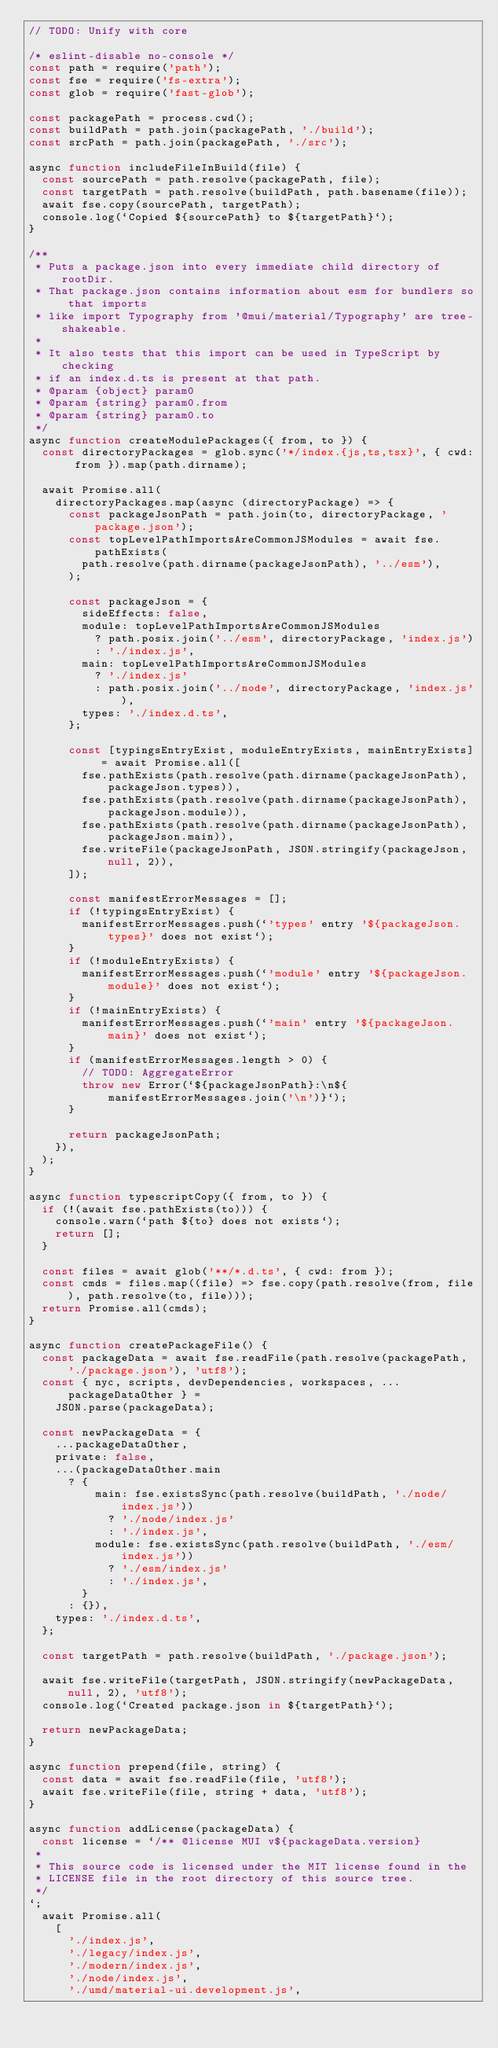Convert code to text. <code><loc_0><loc_0><loc_500><loc_500><_JavaScript_>// TODO: Unify with core

/* eslint-disable no-console */
const path = require('path');
const fse = require('fs-extra');
const glob = require('fast-glob');

const packagePath = process.cwd();
const buildPath = path.join(packagePath, './build');
const srcPath = path.join(packagePath, './src');

async function includeFileInBuild(file) {
  const sourcePath = path.resolve(packagePath, file);
  const targetPath = path.resolve(buildPath, path.basename(file));
  await fse.copy(sourcePath, targetPath);
  console.log(`Copied ${sourcePath} to ${targetPath}`);
}

/**
 * Puts a package.json into every immediate child directory of rootDir.
 * That package.json contains information about esm for bundlers so that imports
 * like import Typography from '@mui/material/Typography' are tree-shakeable.
 *
 * It also tests that this import can be used in TypeScript by checking
 * if an index.d.ts is present at that path.
 * @param {object} param0
 * @param {string} param0.from
 * @param {string} param0.to
 */
async function createModulePackages({ from, to }) {
  const directoryPackages = glob.sync('*/index.{js,ts,tsx}', { cwd: from }).map(path.dirname);

  await Promise.all(
    directoryPackages.map(async (directoryPackage) => {
      const packageJsonPath = path.join(to, directoryPackage, 'package.json');
      const topLevelPathImportsAreCommonJSModules = await fse.pathExists(
        path.resolve(path.dirname(packageJsonPath), '../esm'),
      );

      const packageJson = {
        sideEffects: false,
        module: topLevelPathImportsAreCommonJSModules
          ? path.posix.join('../esm', directoryPackage, 'index.js')
          : './index.js',
        main: topLevelPathImportsAreCommonJSModules
          ? './index.js'
          : path.posix.join('../node', directoryPackage, 'index.js'),
        types: './index.d.ts',
      };

      const [typingsEntryExist, moduleEntryExists, mainEntryExists] = await Promise.all([
        fse.pathExists(path.resolve(path.dirname(packageJsonPath), packageJson.types)),
        fse.pathExists(path.resolve(path.dirname(packageJsonPath), packageJson.module)),
        fse.pathExists(path.resolve(path.dirname(packageJsonPath), packageJson.main)),
        fse.writeFile(packageJsonPath, JSON.stringify(packageJson, null, 2)),
      ]);

      const manifestErrorMessages = [];
      if (!typingsEntryExist) {
        manifestErrorMessages.push(`'types' entry '${packageJson.types}' does not exist`);
      }
      if (!moduleEntryExists) {
        manifestErrorMessages.push(`'module' entry '${packageJson.module}' does not exist`);
      }
      if (!mainEntryExists) {
        manifestErrorMessages.push(`'main' entry '${packageJson.main}' does not exist`);
      }
      if (manifestErrorMessages.length > 0) {
        // TODO: AggregateError
        throw new Error(`${packageJsonPath}:\n${manifestErrorMessages.join('\n')}`);
      }

      return packageJsonPath;
    }),
  );
}

async function typescriptCopy({ from, to }) {
  if (!(await fse.pathExists(to))) {
    console.warn(`path ${to} does not exists`);
    return [];
  }

  const files = await glob('**/*.d.ts', { cwd: from });
  const cmds = files.map((file) => fse.copy(path.resolve(from, file), path.resolve(to, file)));
  return Promise.all(cmds);
}

async function createPackageFile() {
  const packageData = await fse.readFile(path.resolve(packagePath, './package.json'), 'utf8');
  const { nyc, scripts, devDependencies, workspaces, ...packageDataOther } =
    JSON.parse(packageData);

  const newPackageData = {
    ...packageDataOther,
    private: false,
    ...(packageDataOther.main
      ? {
          main: fse.existsSync(path.resolve(buildPath, './node/index.js'))
            ? './node/index.js'
            : './index.js',
          module: fse.existsSync(path.resolve(buildPath, './esm/index.js'))
            ? './esm/index.js'
            : './index.js',
        }
      : {}),
    types: './index.d.ts',
  };

  const targetPath = path.resolve(buildPath, './package.json');

  await fse.writeFile(targetPath, JSON.stringify(newPackageData, null, 2), 'utf8');
  console.log(`Created package.json in ${targetPath}`);

  return newPackageData;
}

async function prepend(file, string) {
  const data = await fse.readFile(file, 'utf8');
  await fse.writeFile(file, string + data, 'utf8');
}

async function addLicense(packageData) {
  const license = `/** @license MUI v${packageData.version}
 *
 * This source code is licensed under the MIT license found in the
 * LICENSE file in the root directory of this source tree.
 */
`;
  await Promise.all(
    [
      './index.js',
      './legacy/index.js',
      './modern/index.js',
      './node/index.js',
      './umd/material-ui.development.js',</code> 